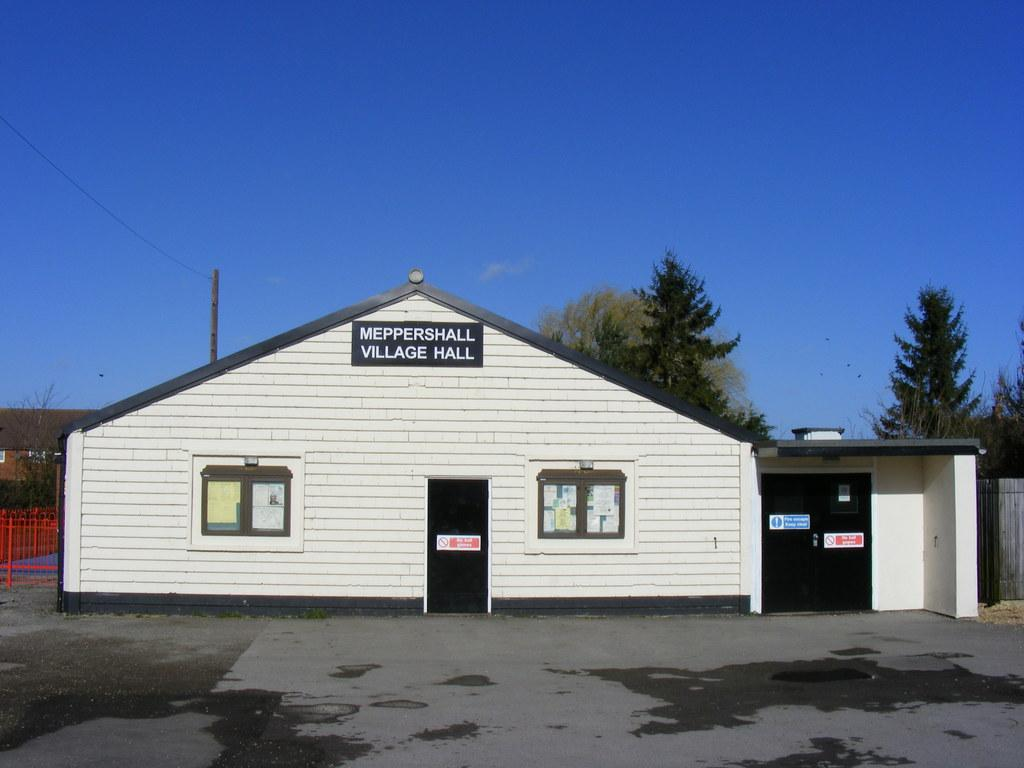What is the color of the sky in the image? The sky is blue in color. What type of structures can be seen in the image? There are houses with windows in the image. What type of vegetation is present in the image? Trees are present in the image. What type of barrier can be seen in the image? There is a red fence in the image. What is on the windows of the houses? Posters are on the windows of the houses. What is on the black doors in the image? Sign boards are on black doors. What type of appliance is being used to cook the bun in the image? There is no bun or appliance present in the image. How many fifth elements are visible in the image? The term "fifth element" is not mentioned in the provided facts, and therefore it cannot be answered definitively. 